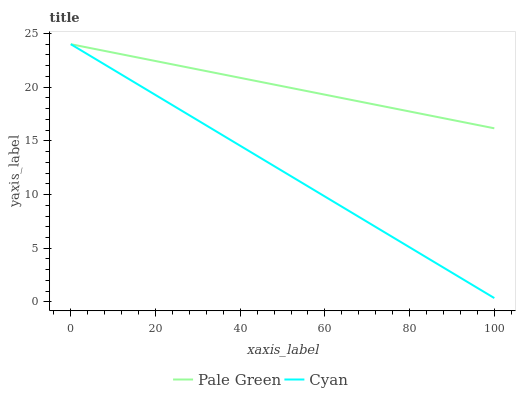Does Cyan have the minimum area under the curve?
Answer yes or no. Yes. Does Pale Green have the maximum area under the curve?
Answer yes or no. Yes. Does Pale Green have the minimum area under the curve?
Answer yes or no. No. Is Cyan the smoothest?
Answer yes or no. Yes. Is Pale Green the roughest?
Answer yes or no. Yes. Is Pale Green the smoothest?
Answer yes or no. No. Does Pale Green have the lowest value?
Answer yes or no. No. Does Pale Green have the highest value?
Answer yes or no. Yes. Does Cyan intersect Pale Green?
Answer yes or no. Yes. Is Cyan less than Pale Green?
Answer yes or no. No. Is Cyan greater than Pale Green?
Answer yes or no. No. 